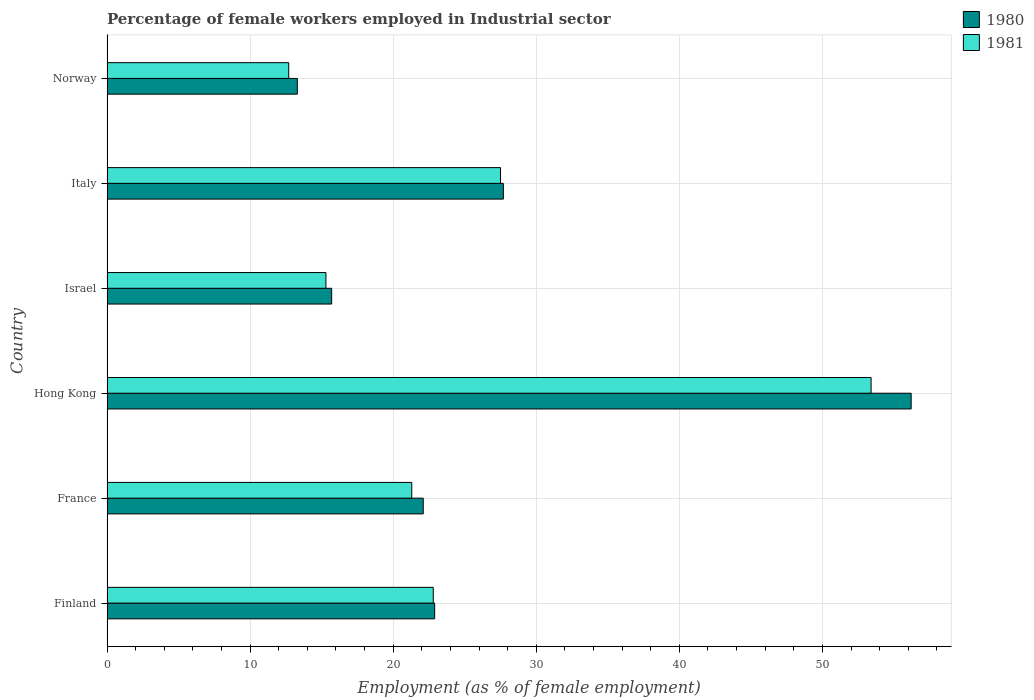How many different coloured bars are there?
Your answer should be very brief. 2. Are the number of bars per tick equal to the number of legend labels?
Offer a very short reply. Yes. What is the label of the 5th group of bars from the top?
Your response must be concise. France. What is the percentage of females employed in Industrial sector in 1981 in France?
Provide a short and direct response. 21.3. Across all countries, what is the maximum percentage of females employed in Industrial sector in 1981?
Give a very brief answer. 53.4. Across all countries, what is the minimum percentage of females employed in Industrial sector in 1980?
Provide a short and direct response. 13.3. In which country was the percentage of females employed in Industrial sector in 1980 maximum?
Offer a very short reply. Hong Kong. What is the total percentage of females employed in Industrial sector in 1980 in the graph?
Your answer should be compact. 157.9. What is the difference between the percentage of females employed in Industrial sector in 1981 in France and that in Italy?
Make the answer very short. -6.2. What is the difference between the percentage of females employed in Industrial sector in 1980 in Finland and the percentage of females employed in Industrial sector in 1981 in Israel?
Provide a short and direct response. 7.6. What is the average percentage of females employed in Industrial sector in 1981 per country?
Your response must be concise. 25.5. What is the difference between the percentage of females employed in Industrial sector in 1980 and percentage of females employed in Industrial sector in 1981 in Finland?
Your answer should be very brief. 0.1. What is the ratio of the percentage of females employed in Industrial sector in 1980 in France to that in Hong Kong?
Give a very brief answer. 0.39. What is the difference between the highest and the second highest percentage of females employed in Industrial sector in 1980?
Your answer should be compact. 28.5. What is the difference between the highest and the lowest percentage of females employed in Industrial sector in 1980?
Your answer should be very brief. 42.9. In how many countries, is the percentage of females employed in Industrial sector in 1980 greater than the average percentage of females employed in Industrial sector in 1980 taken over all countries?
Offer a very short reply. 2. Is the sum of the percentage of females employed in Industrial sector in 1981 in Hong Kong and Italy greater than the maximum percentage of females employed in Industrial sector in 1980 across all countries?
Make the answer very short. Yes. How many bars are there?
Offer a terse response. 12. How many countries are there in the graph?
Keep it short and to the point. 6. Are the values on the major ticks of X-axis written in scientific E-notation?
Offer a very short reply. No. Does the graph contain any zero values?
Offer a very short reply. No. Where does the legend appear in the graph?
Offer a terse response. Top right. How many legend labels are there?
Offer a very short reply. 2. What is the title of the graph?
Keep it short and to the point. Percentage of female workers employed in Industrial sector. What is the label or title of the X-axis?
Make the answer very short. Employment (as % of female employment). What is the label or title of the Y-axis?
Your answer should be very brief. Country. What is the Employment (as % of female employment) in 1980 in Finland?
Offer a terse response. 22.9. What is the Employment (as % of female employment) in 1981 in Finland?
Provide a succinct answer. 22.8. What is the Employment (as % of female employment) in 1980 in France?
Keep it short and to the point. 22.1. What is the Employment (as % of female employment) in 1981 in France?
Provide a short and direct response. 21.3. What is the Employment (as % of female employment) of 1980 in Hong Kong?
Give a very brief answer. 56.2. What is the Employment (as % of female employment) in 1981 in Hong Kong?
Make the answer very short. 53.4. What is the Employment (as % of female employment) in 1980 in Israel?
Give a very brief answer. 15.7. What is the Employment (as % of female employment) in 1981 in Israel?
Provide a succinct answer. 15.3. What is the Employment (as % of female employment) in 1980 in Italy?
Ensure brevity in your answer.  27.7. What is the Employment (as % of female employment) of 1980 in Norway?
Provide a succinct answer. 13.3. What is the Employment (as % of female employment) in 1981 in Norway?
Give a very brief answer. 12.7. Across all countries, what is the maximum Employment (as % of female employment) in 1980?
Provide a succinct answer. 56.2. Across all countries, what is the maximum Employment (as % of female employment) of 1981?
Provide a short and direct response. 53.4. Across all countries, what is the minimum Employment (as % of female employment) of 1980?
Your answer should be compact. 13.3. Across all countries, what is the minimum Employment (as % of female employment) of 1981?
Your answer should be very brief. 12.7. What is the total Employment (as % of female employment) in 1980 in the graph?
Provide a short and direct response. 157.9. What is the total Employment (as % of female employment) of 1981 in the graph?
Your answer should be very brief. 153. What is the difference between the Employment (as % of female employment) in 1980 in Finland and that in France?
Offer a terse response. 0.8. What is the difference between the Employment (as % of female employment) of 1981 in Finland and that in France?
Give a very brief answer. 1.5. What is the difference between the Employment (as % of female employment) in 1980 in Finland and that in Hong Kong?
Give a very brief answer. -33.3. What is the difference between the Employment (as % of female employment) of 1981 in Finland and that in Hong Kong?
Offer a terse response. -30.6. What is the difference between the Employment (as % of female employment) in 1980 in Finland and that in Israel?
Your answer should be very brief. 7.2. What is the difference between the Employment (as % of female employment) in 1981 in Finland and that in Israel?
Your answer should be very brief. 7.5. What is the difference between the Employment (as % of female employment) of 1980 in France and that in Hong Kong?
Give a very brief answer. -34.1. What is the difference between the Employment (as % of female employment) of 1981 in France and that in Hong Kong?
Offer a terse response. -32.1. What is the difference between the Employment (as % of female employment) of 1980 in France and that in Israel?
Offer a terse response. 6.4. What is the difference between the Employment (as % of female employment) in 1981 in France and that in Israel?
Your answer should be compact. 6. What is the difference between the Employment (as % of female employment) in 1980 in France and that in Italy?
Your answer should be very brief. -5.6. What is the difference between the Employment (as % of female employment) in 1981 in France and that in Norway?
Give a very brief answer. 8.6. What is the difference between the Employment (as % of female employment) in 1980 in Hong Kong and that in Israel?
Ensure brevity in your answer.  40.5. What is the difference between the Employment (as % of female employment) in 1981 in Hong Kong and that in Israel?
Provide a succinct answer. 38.1. What is the difference between the Employment (as % of female employment) of 1980 in Hong Kong and that in Italy?
Your response must be concise. 28.5. What is the difference between the Employment (as % of female employment) in 1981 in Hong Kong and that in Italy?
Provide a succinct answer. 25.9. What is the difference between the Employment (as % of female employment) of 1980 in Hong Kong and that in Norway?
Your answer should be very brief. 42.9. What is the difference between the Employment (as % of female employment) in 1981 in Hong Kong and that in Norway?
Your response must be concise. 40.7. What is the difference between the Employment (as % of female employment) of 1981 in Italy and that in Norway?
Your answer should be very brief. 14.8. What is the difference between the Employment (as % of female employment) in 1980 in Finland and the Employment (as % of female employment) in 1981 in Hong Kong?
Keep it short and to the point. -30.5. What is the difference between the Employment (as % of female employment) of 1980 in Finland and the Employment (as % of female employment) of 1981 in Israel?
Offer a terse response. 7.6. What is the difference between the Employment (as % of female employment) of 1980 in Finland and the Employment (as % of female employment) of 1981 in Italy?
Give a very brief answer. -4.6. What is the difference between the Employment (as % of female employment) in 1980 in Finland and the Employment (as % of female employment) in 1981 in Norway?
Keep it short and to the point. 10.2. What is the difference between the Employment (as % of female employment) in 1980 in France and the Employment (as % of female employment) in 1981 in Hong Kong?
Your answer should be compact. -31.3. What is the difference between the Employment (as % of female employment) of 1980 in Hong Kong and the Employment (as % of female employment) of 1981 in Israel?
Your answer should be compact. 40.9. What is the difference between the Employment (as % of female employment) in 1980 in Hong Kong and the Employment (as % of female employment) in 1981 in Italy?
Your response must be concise. 28.7. What is the difference between the Employment (as % of female employment) of 1980 in Hong Kong and the Employment (as % of female employment) of 1981 in Norway?
Your answer should be very brief. 43.5. What is the difference between the Employment (as % of female employment) of 1980 in Israel and the Employment (as % of female employment) of 1981 in Norway?
Give a very brief answer. 3. What is the average Employment (as % of female employment) in 1980 per country?
Your answer should be very brief. 26.32. What is the ratio of the Employment (as % of female employment) of 1980 in Finland to that in France?
Offer a very short reply. 1.04. What is the ratio of the Employment (as % of female employment) in 1981 in Finland to that in France?
Offer a very short reply. 1.07. What is the ratio of the Employment (as % of female employment) in 1980 in Finland to that in Hong Kong?
Keep it short and to the point. 0.41. What is the ratio of the Employment (as % of female employment) in 1981 in Finland to that in Hong Kong?
Offer a terse response. 0.43. What is the ratio of the Employment (as % of female employment) in 1980 in Finland to that in Israel?
Provide a succinct answer. 1.46. What is the ratio of the Employment (as % of female employment) in 1981 in Finland to that in Israel?
Offer a very short reply. 1.49. What is the ratio of the Employment (as % of female employment) in 1980 in Finland to that in Italy?
Offer a terse response. 0.83. What is the ratio of the Employment (as % of female employment) in 1981 in Finland to that in Italy?
Offer a terse response. 0.83. What is the ratio of the Employment (as % of female employment) in 1980 in Finland to that in Norway?
Your answer should be very brief. 1.72. What is the ratio of the Employment (as % of female employment) of 1981 in Finland to that in Norway?
Ensure brevity in your answer.  1.8. What is the ratio of the Employment (as % of female employment) of 1980 in France to that in Hong Kong?
Offer a terse response. 0.39. What is the ratio of the Employment (as % of female employment) of 1981 in France to that in Hong Kong?
Provide a succinct answer. 0.4. What is the ratio of the Employment (as % of female employment) in 1980 in France to that in Israel?
Provide a succinct answer. 1.41. What is the ratio of the Employment (as % of female employment) in 1981 in France to that in Israel?
Your answer should be very brief. 1.39. What is the ratio of the Employment (as % of female employment) of 1980 in France to that in Italy?
Make the answer very short. 0.8. What is the ratio of the Employment (as % of female employment) of 1981 in France to that in Italy?
Your response must be concise. 0.77. What is the ratio of the Employment (as % of female employment) in 1980 in France to that in Norway?
Keep it short and to the point. 1.66. What is the ratio of the Employment (as % of female employment) in 1981 in France to that in Norway?
Provide a succinct answer. 1.68. What is the ratio of the Employment (as % of female employment) in 1980 in Hong Kong to that in Israel?
Provide a succinct answer. 3.58. What is the ratio of the Employment (as % of female employment) in 1981 in Hong Kong to that in Israel?
Provide a short and direct response. 3.49. What is the ratio of the Employment (as % of female employment) of 1980 in Hong Kong to that in Italy?
Offer a very short reply. 2.03. What is the ratio of the Employment (as % of female employment) in 1981 in Hong Kong to that in Italy?
Provide a short and direct response. 1.94. What is the ratio of the Employment (as % of female employment) of 1980 in Hong Kong to that in Norway?
Give a very brief answer. 4.23. What is the ratio of the Employment (as % of female employment) of 1981 in Hong Kong to that in Norway?
Offer a very short reply. 4.2. What is the ratio of the Employment (as % of female employment) in 1980 in Israel to that in Italy?
Offer a very short reply. 0.57. What is the ratio of the Employment (as % of female employment) in 1981 in Israel to that in Italy?
Offer a terse response. 0.56. What is the ratio of the Employment (as % of female employment) in 1980 in Israel to that in Norway?
Ensure brevity in your answer.  1.18. What is the ratio of the Employment (as % of female employment) of 1981 in Israel to that in Norway?
Provide a short and direct response. 1.2. What is the ratio of the Employment (as % of female employment) of 1980 in Italy to that in Norway?
Provide a succinct answer. 2.08. What is the ratio of the Employment (as % of female employment) of 1981 in Italy to that in Norway?
Offer a very short reply. 2.17. What is the difference between the highest and the second highest Employment (as % of female employment) of 1980?
Your answer should be very brief. 28.5. What is the difference between the highest and the second highest Employment (as % of female employment) of 1981?
Provide a short and direct response. 25.9. What is the difference between the highest and the lowest Employment (as % of female employment) of 1980?
Provide a succinct answer. 42.9. What is the difference between the highest and the lowest Employment (as % of female employment) of 1981?
Offer a terse response. 40.7. 